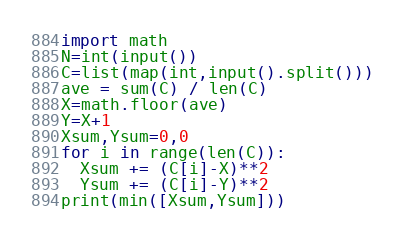Convert code to text. <code><loc_0><loc_0><loc_500><loc_500><_Python_>import math
N=int(input())
C=list(map(int,input().split()))
ave = sum(C) / len(C)
X=math.floor(ave)
Y=X+1
Xsum,Ysum=0,0
for i in range(len(C)):
  Xsum += (C[i]-X)**2
  Ysum += (C[i]-Y)**2
print(min([Xsum,Ysum]))</code> 